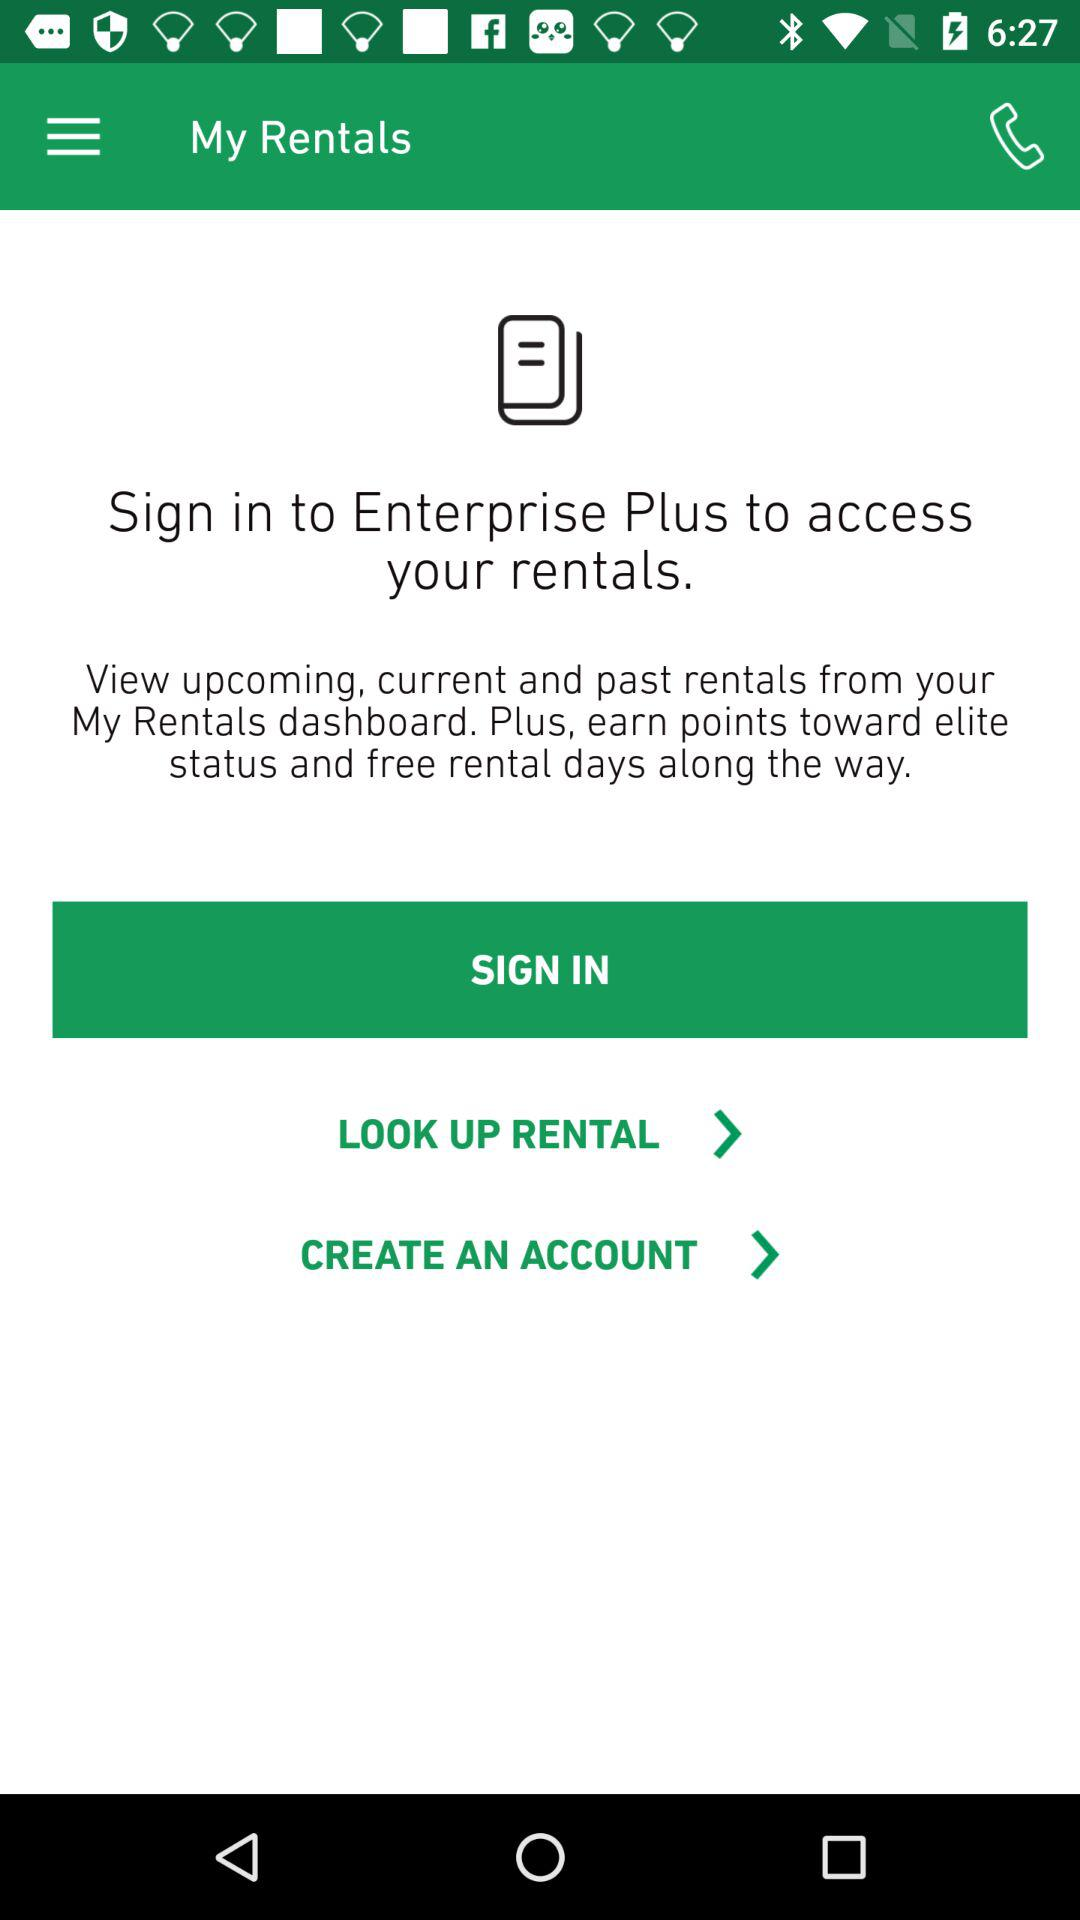What is the name of the application?
When the provided information is insufficient, respond with <no answer>. <no answer> 